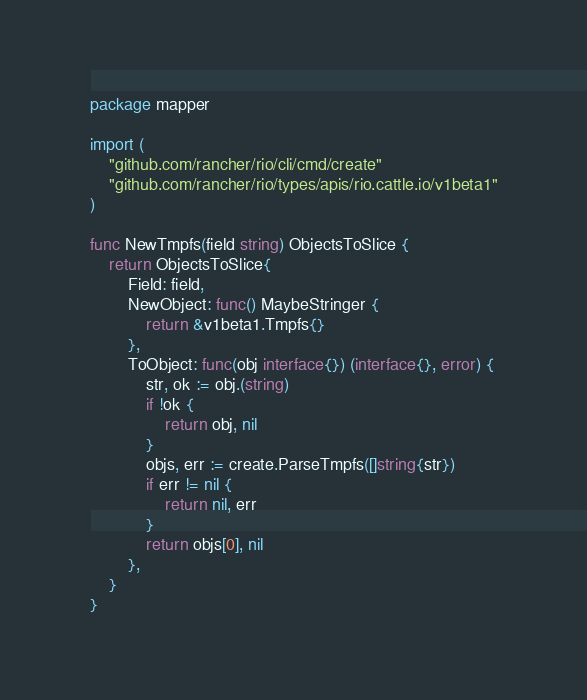<code> <loc_0><loc_0><loc_500><loc_500><_Go_>package mapper

import (
	"github.com/rancher/rio/cli/cmd/create"
	"github.com/rancher/rio/types/apis/rio.cattle.io/v1beta1"
)

func NewTmpfs(field string) ObjectsToSlice {
	return ObjectsToSlice{
		Field: field,
		NewObject: func() MaybeStringer {
			return &v1beta1.Tmpfs{}
		},
		ToObject: func(obj interface{}) (interface{}, error) {
			str, ok := obj.(string)
			if !ok {
				return obj, nil
			}
			objs, err := create.ParseTmpfs([]string{str})
			if err != nil {
				return nil, err
			}
			return objs[0], nil
		},
	}
}
</code> 